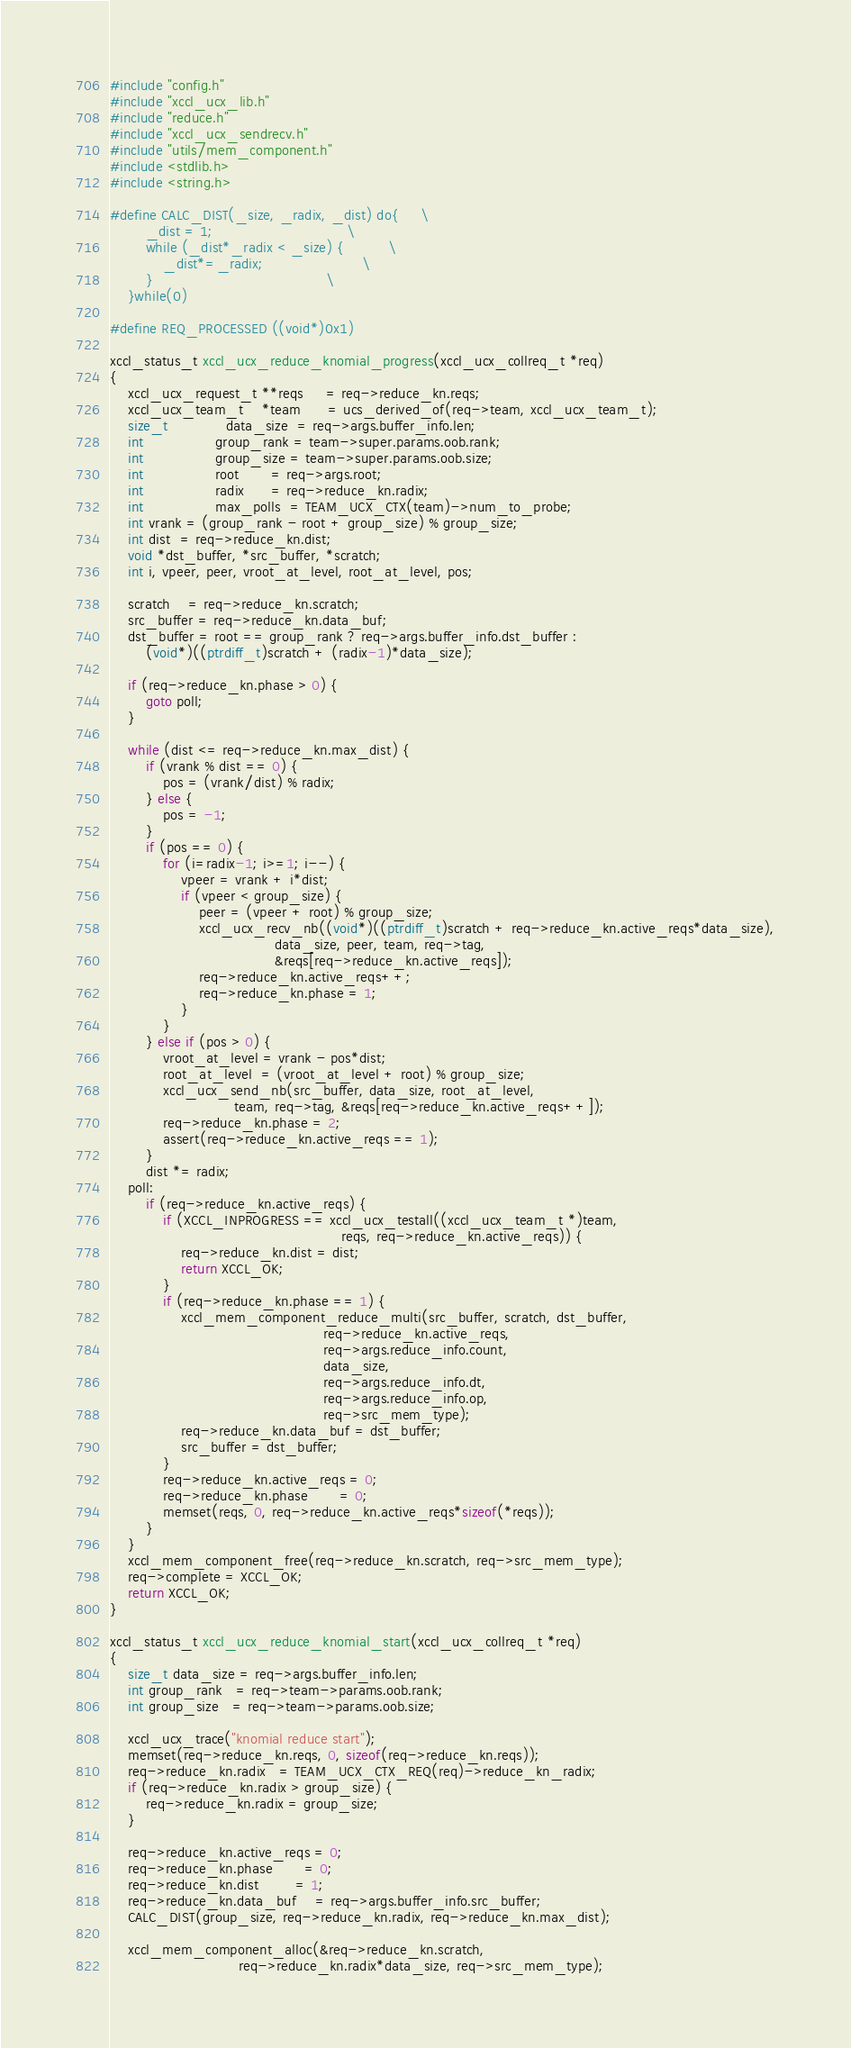Convert code to text. <code><loc_0><loc_0><loc_500><loc_500><_C_>#include "config.h"
#include "xccl_ucx_lib.h"
#include "reduce.h"
#include "xccl_ucx_sendrecv.h"
#include "utils/mem_component.h"
#include <stdlib.h>
#include <string.h>

#define CALC_DIST(_size, _radix, _dist) do{     \
        _dist = 1;                              \
        while (_dist*_radix < _size) {          \
            _dist*=_radix;                      \
        }                                       \
    }while(0)

#define REQ_PROCESSED ((void*)0x1)

xccl_status_t xccl_ucx_reduce_knomial_progress(xccl_ucx_collreq_t *req)
{
    xccl_ucx_request_t **reqs     = req->reduce_kn.reqs;
    xccl_ucx_team_t    *team      = ucs_derived_of(req->team, xccl_ucx_team_t);
    size_t             data_size  = req->args.buffer_info.len;
    int                group_rank = team->super.params.oob.rank;
    int                group_size = team->super.params.oob.size;
    int                root       = req->args.root;
    int                radix      = req->reduce_kn.radix;
    int                max_polls  = TEAM_UCX_CTX(team)->num_to_probe;
    int vrank = (group_rank - root + group_size) % group_size;
    int dist  = req->reduce_kn.dist;
    void *dst_buffer, *src_buffer, *scratch;
    int i, vpeer, peer, vroot_at_level, root_at_level, pos;

    scratch    = req->reduce_kn.scratch;
    src_buffer = req->reduce_kn.data_buf;
    dst_buffer = root == group_rank ? req->args.buffer_info.dst_buffer :
        (void*)((ptrdiff_t)scratch + (radix-1)*data_size);

    if (req->reduce_kn.phase > 0) {
        goto poll;
    }

    while (dist <= req->reduce_kn.max_dist) {
        if (vrank % dist == 0) {
            pos = (vrank/dist) % radix;
        } else {
            pos = -1;
        }
        if (pos == 0) {
            for (i=radix-1; i>=1; i--) {
                vpeer = vrank + i*dist;
                if (vpeer < group_size) {
                    peer = (vpeer + root) % group_size;
                    xccl_ucx_recv_nb((void*)((ptrdiff_t)scratch + req->reduce_kn.active_reqs*data_size),
                                     data_size, peer, team, req->tag,
                                     &reqs[req->reduce_kn.active_reqs]);
                    req->reduce_kn.active_reqs++;
                    req->reduce_kn.phase = 1;
                }
            }
        } else if (pos > 0) {
            vroot_at_level = vrank - pos*dist;
            root_at_level  = (vroot_at_level + root) % group_size;
            xccl_ucx_send_nb(src_buffer, data_size, root_at_level,
                            team, req->tag, &reqs[req->reduce_kn.active_reqs++]);
            req->reduce_kn.phase = 2;
            assert(req->reduce_kn.active_reqs == 1);
        }
        dist *= radix;
    poll:
        if (req->reduce_kn.active_reqs) {
            if (XCCL_INPROGRESS == xccl_ucx_testall((xccl_ucx_team_t *)team,
                                                    reqs, req->reduce_kn.active_reqs)) {
                req->reduce_kn.dist = dist;
                return XCCL_OK;
            }
            if (req->reduce_kn.phase == 1) {
                xccl_mem_component_reduce_multi(src_buffer, scratch, dst_buffer,
                                                req->reduce_kn.active_reqs,
                                                req->args.reduce_info.count,
                                                data_size,
                                                req->args.reduce_info.dt,
                                                req->args.reduce_info.op,
                                                req->src_mem_type);
                req->reduce_kn.data_buf = dst_buffer;
                src_buffer = dst_buffer;
            }
            req->reduce_kn.active_reqs = 0;
            req->reduce_kn.phase       = 0;
            memset(reqs, 0, req->reduce_kn.active_reqs*sizeof(*reqs));
        }
    }
    xccl_mem_component_free(req->reduce_kn.scratch, req->src_mem_type);
    req->complete = XCCL_OK;
    return XCCL_OK;
}

xccl_status_t xccl_ucx_reduce_knomial_start(xccl_ucx_collreq_t *req)
{
    size_t data_size = req->args.buffer_info.len;
    int group_rank   = req->team->params.oob.rank;
    int group_size   = req->team->params.oob.size;

    xccl_ucx_trace("knomial reduce start");
    memset(req->reduce_kn.reqs, 0, sizeof(req->reduce_kn.reqs));
    req->reduce_kn.radix   = TEAM_UCX_CTX_REQ(req)->reduce_kn_radix;
    if (req->reduce_kn.radix > group_size) {
        req->reduce_kn.radix = group_size;
    }

    req->reduce_kn.active_reqs = 0;
    req->reduce_kn.phase       = 0;
    req->reduce_kn.dist        = 1;
    req->reduce_kn.data_buf    = req->args.buffer_info.src_buffer;
    CALC_DIST(group_size, req->reduce_kn.radix, req->reduce_kn.max_dist);

    xccl_mem_component_alloc(&req->reduce_kn.scratch,
                             req->reduce_kn.radix*data_size, req->src_mem_type);</code> 